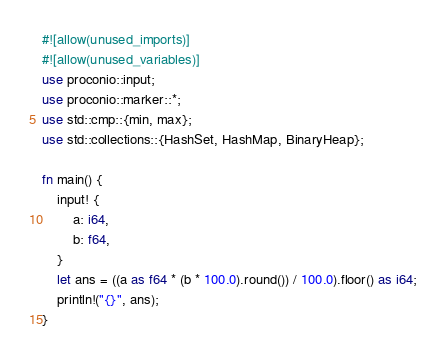<code> <loc_0><loc_0><loc_500><loc_500><_Rust_>#![allow(unused_imports)]
#![allow(unused_variables)]
use proconio::input;
use proconio::marker::*;
use std::cmp::{min, max};
use std::collections::{HashSet, HashMap, BinaryHeap};

fn main() {
    input! {
        a: i64,
        b: f64,
    }
    let ans = ((a as f64 * (b * 100.0).round()) / 100.0).floor() as i64;
    println!("{}", ans);
}
</code> 